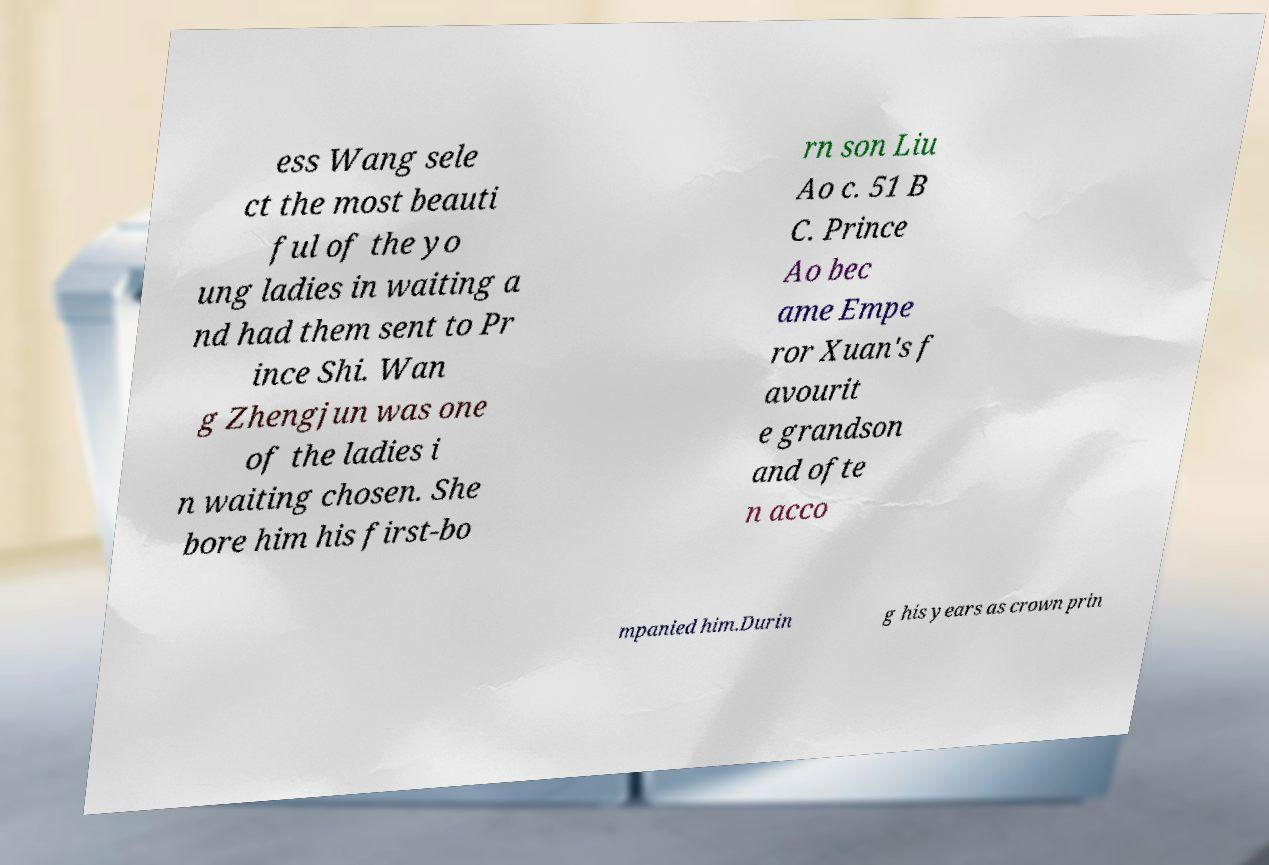Can you accurately transcribe the text from the provided image for me? ess Wang sele ct the most beauti ful of the yo ung ladies in waiting a nd had them sent to Pr ince Shi. Wan g Zhengjun was one of the ladies i n waiting chosen. She bore him his first-bo rn son Liu Ao c. 51 B C. Prince Ao bec ame Empe ror Xuan's f avourit e grandson and ofte n acco mpanied him.Durin g his years as crown prin 